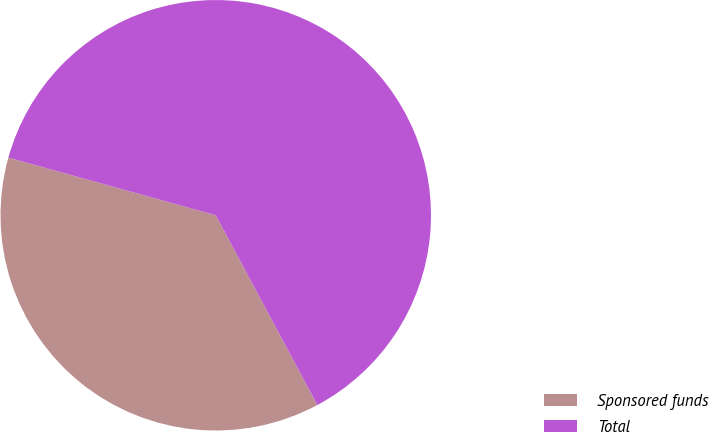Convert chart. <chart><loc_0><loc_0><loc_500><loc_500><pie_chart><fcel>Sponsored funds<fcel>Total<nl><fcel>37.14%<fcel>62.86%<nl></chart> 